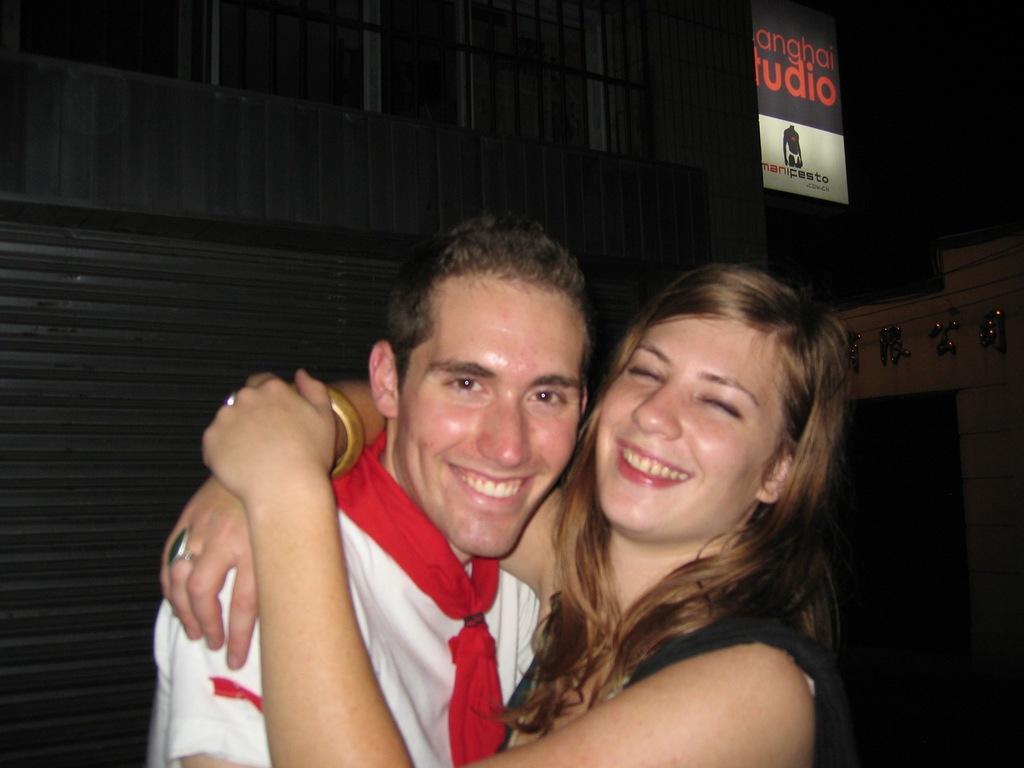Please provide a concise description of this image. In this image, there are two persons wearing clothes and hugging each other. There is a board in the top right of the image. 